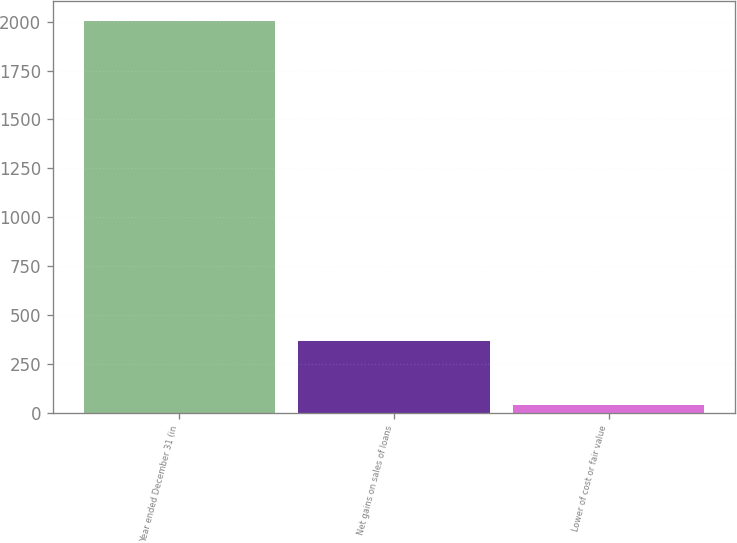Convert chart to OTSL. <chart><loc_0><loc_0><loc_500><loc_500><bar_chart><fcel>Year ended December 31 (in<fcel>Net gains on sales of loans<fcel>Lower of cost or fair value<nl><fcel>2004<fcel>368<fcel>39<nl></chart> 